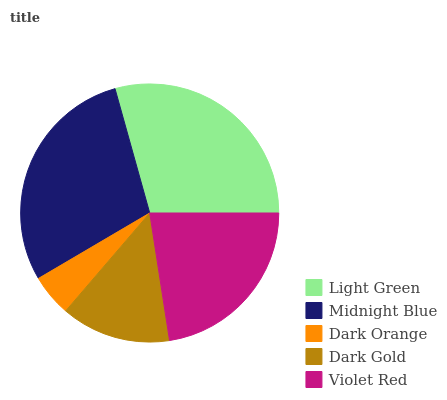Is Dark Orange the minimum?
Answer yes or no. Yes. Is Light Green the maximum?
Answer yes or no. Yes. Is Midnight Blue the minimum?
Answer yes or no. No. Is Midnight Blue the maximum?
Answer yes or no. No. Is Light Green greater than Midnight Blue?
Answer yes or no. Yes. Is Midnight Blue less than Light Green?
Answer yes or no. Yes. Is Midnight Blue greater than Light Green?
Answer yes or no. No. Is Light Green less than Midnight Blue?
Answer yes or no. No. Is Violet Red the high median?
Answer yes or no. Yes. Is Violet Red the low median?
Answer yes or no. Yes. Is Light Green the high median?
Answer yes or no. No. Is Light Green the low median?
Answer yes or no. No. 